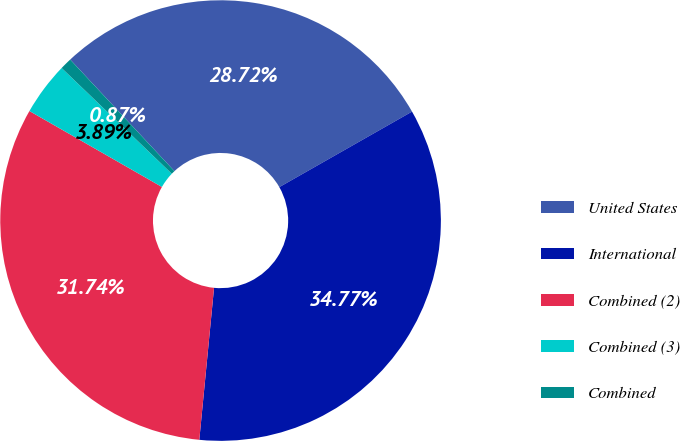Convert chart to OTSL. <chart><loc_0><loc_0><loc_500><loc_500><pie_chart><fcel>United States<fcel>International<fcel>Combined (2)<fcel>Combined (3)<fcel>Combined<nl><fcel>28.72%<fcel>34.77%<fcel>31.74%<fcel>3.89%<fcel>0.87%<nl></chart> 